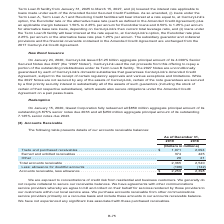According to Centurylink's financial document, How is the purchase of accounts receivable from other communications service providers done? primarily on a recourse basis. The document states: "vable from other communications service providers primarily on a recourse basis and include these amounts in our accounts receivable balance. We have ..." Also, What do the agreements with other communications service providers comprise of? agree to bill and collect on their behalf for services rendered by those providers to our customers within our local service area. The document states: "other communications service providers whereby we agree to bill and collect on their behalf for services rendered by those providers to our customers ..." Also, What are the types of accounts receivables highlighted in the table? The document contains multiple relevant values: Trade and purchased receivables, Earned and unbilled receivables, Other. From the document: ") Trade and purchased receivables . $ 1,971 2,094 Earned and unbilled receivables . 374 425 Other . 20 21 (Dollars in millions) Trade and purchased re..." Also, How many types of accounts receivables are highlighted in the table? Counting the relevant items in the document: Trade and purchased receivables, Earned and unbilled receivables, Other, I find 3 instances. The key data points involved are: Earned and unbilled receivables, Other, Trade and purchased receivables. Also, can you calculate: What is the change in the earned and unbilled receivables? Based on the calculation: 374-425, the result is -51 (in millions). This is based on the information: "1,971 2,094 Earned and unbilled receivables . 374 425 Other . 20 21 . $ 1,971 2,094 Earned and unbilled receivables . 374 425 Other . 20 21..." The key data points involved are: 374, 425. Also, can you calculate: What is the percentage change in the earned and unbilled receivables? To answer this question, I need to perform calculations using the financial data. The calculation is: (374-425)/425, which equals -12 (percentage). This is based on the information: "1,971 2,094 Earned and unbilled receivables . 374 425 Other . 20 21 . $ 1,971 2,094 Earned and unbilled receivables . 374 425 Other . 20 21..." The key data points involved are: 374, 425. 